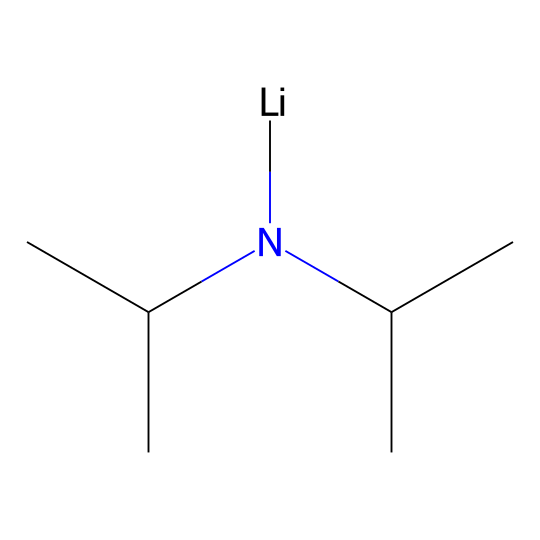What is the primary functional group in lithium diisopropylamide? The structure shows a nitrogen atom bonded to two isopropyl groups, indicating it is an amide.
Answer: amide How many carbon atoms are present in lithium diisopropylamide? Counting the carbon atoms in the isopropyl groups (each contributes three carbons) and the nitrogen connection, there are a total of six carbon atoms.
Answer: six What is the valency of the lithium atom in this compound? Lithium typically has a valency of one, as it forms one bond in this structure.
Answer: one What type of bond connects the lithium atom to the nitrogen atom? Lithium ionically bonds with the nitrogen atom, indicating a strong intermolecular interaction.
Answer: ionic What can be inferred about the strength of lithium diisopropylamide as a base? Given its structure, specifically the electron-donating properties of the isopropyl groups and the presence of lithium, it is classified as a strong base.
Answer: strong base Does lithium diisopropylamide contain any aromatic rings? The structure does not exhibit any cyclic, conjugated arrangements or double bonds that would characterize an aromatic compound.
Answer: no 